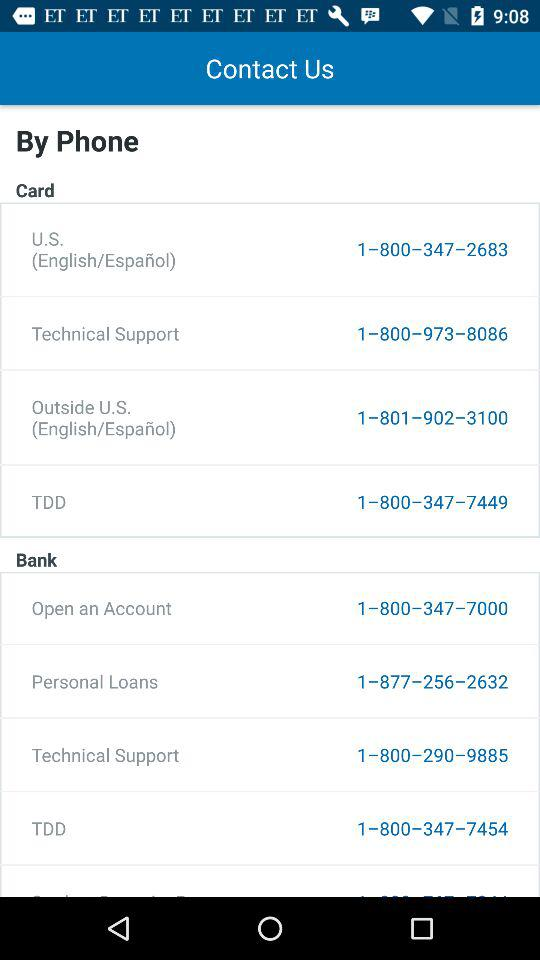What is the contact number for TDD? The contact numbers for TDD are 1-800-347-7449 and 1-800-347-7454. 